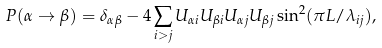Convert formula to latex. <formula><loc_0><loc_0><loc_500><loc_500>P ( \alpha \rightarrow \beta ) = \delta _ { \alpha \beta } - 4 \sum _ { i > j } U _ { \alpha i } U _ { \beta i } U _ { \alpha j } U _ { \beta j } \sin ^ { 2 } ( \pi L / \lambda _ { i j } ) ,</formula> 